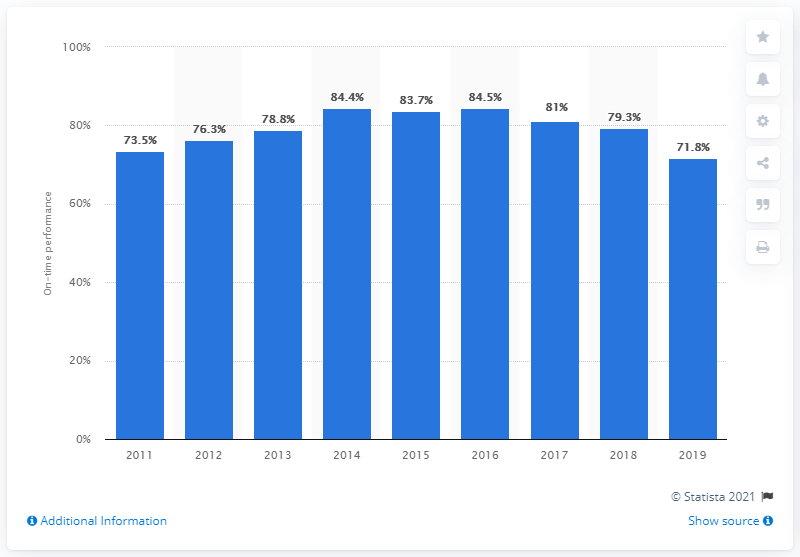Indicate a few pertinent items in this graphic. The on-time performance of Wizz Air in the financial year ending on March 31, 2019, was 71.8%. 